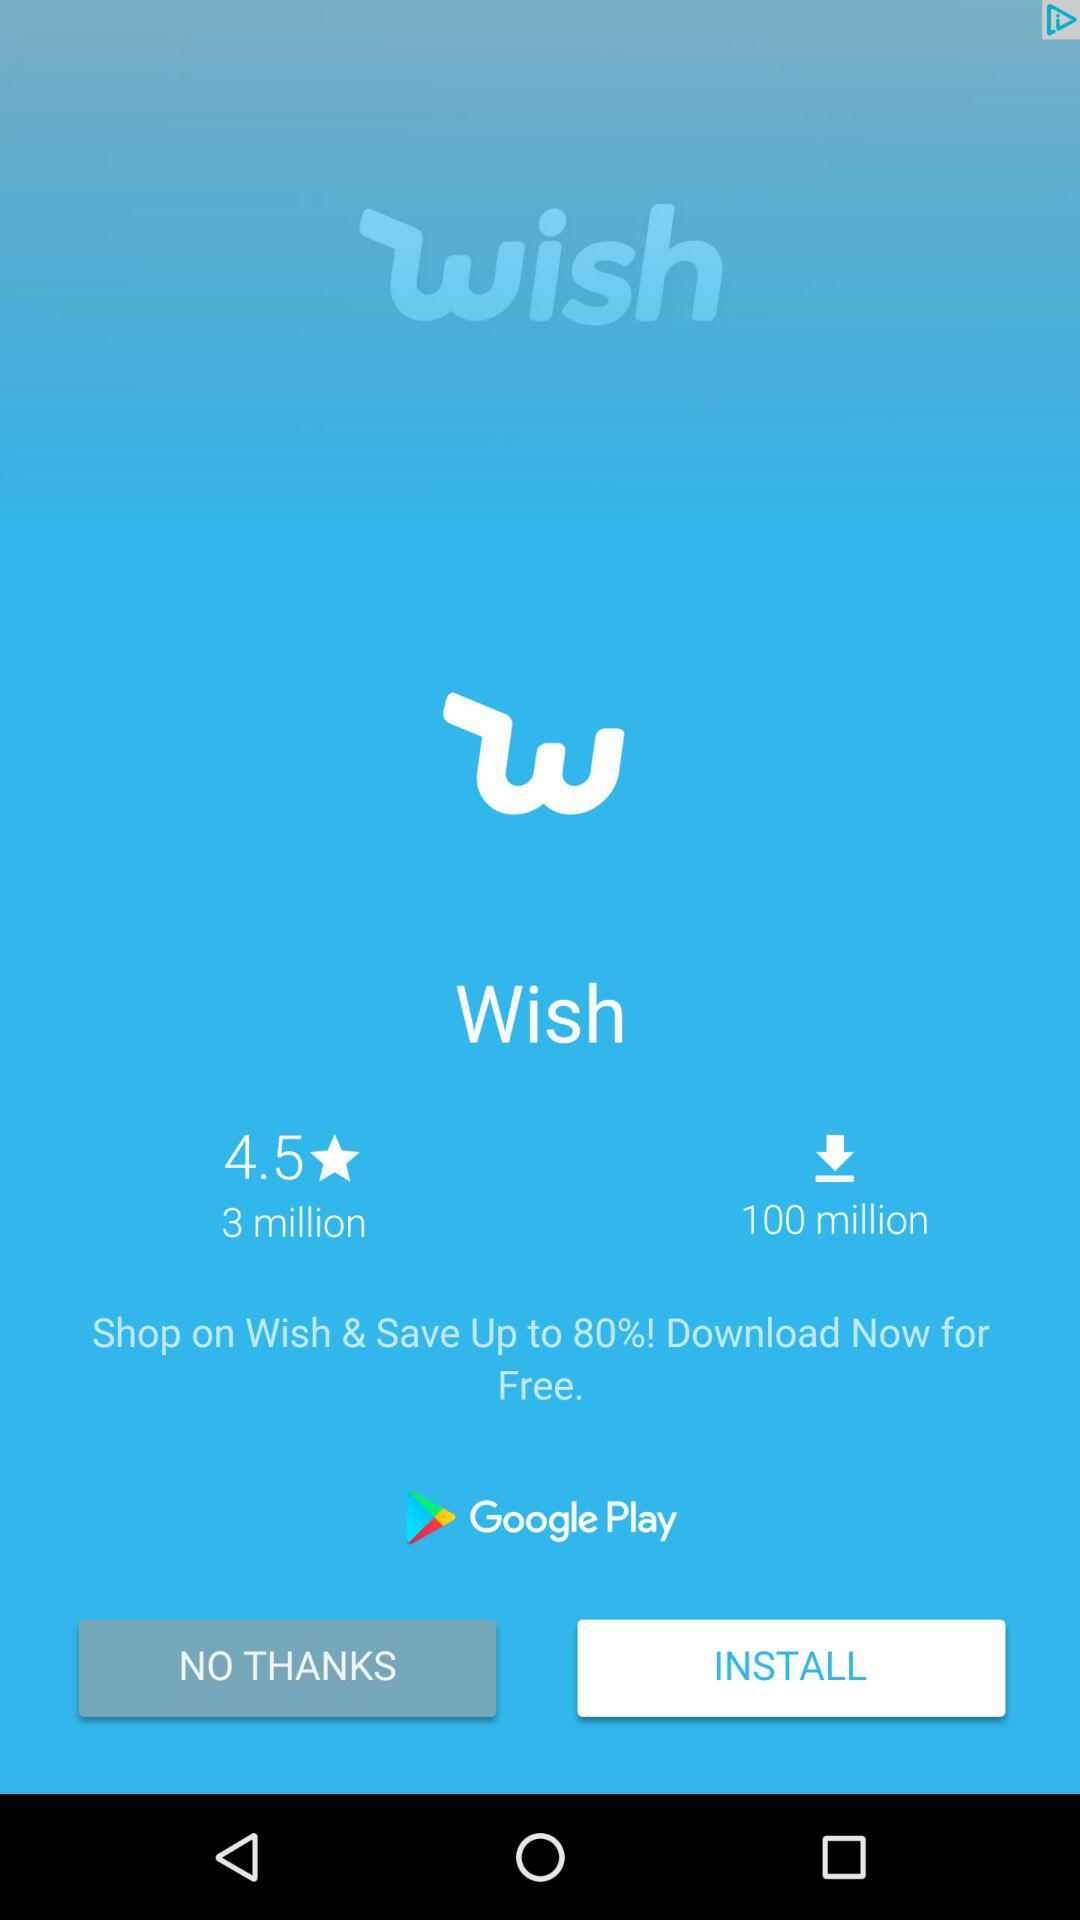How many more downloads does Wish have than reviews?
Answer the question using a single word or phrase. 97 million 